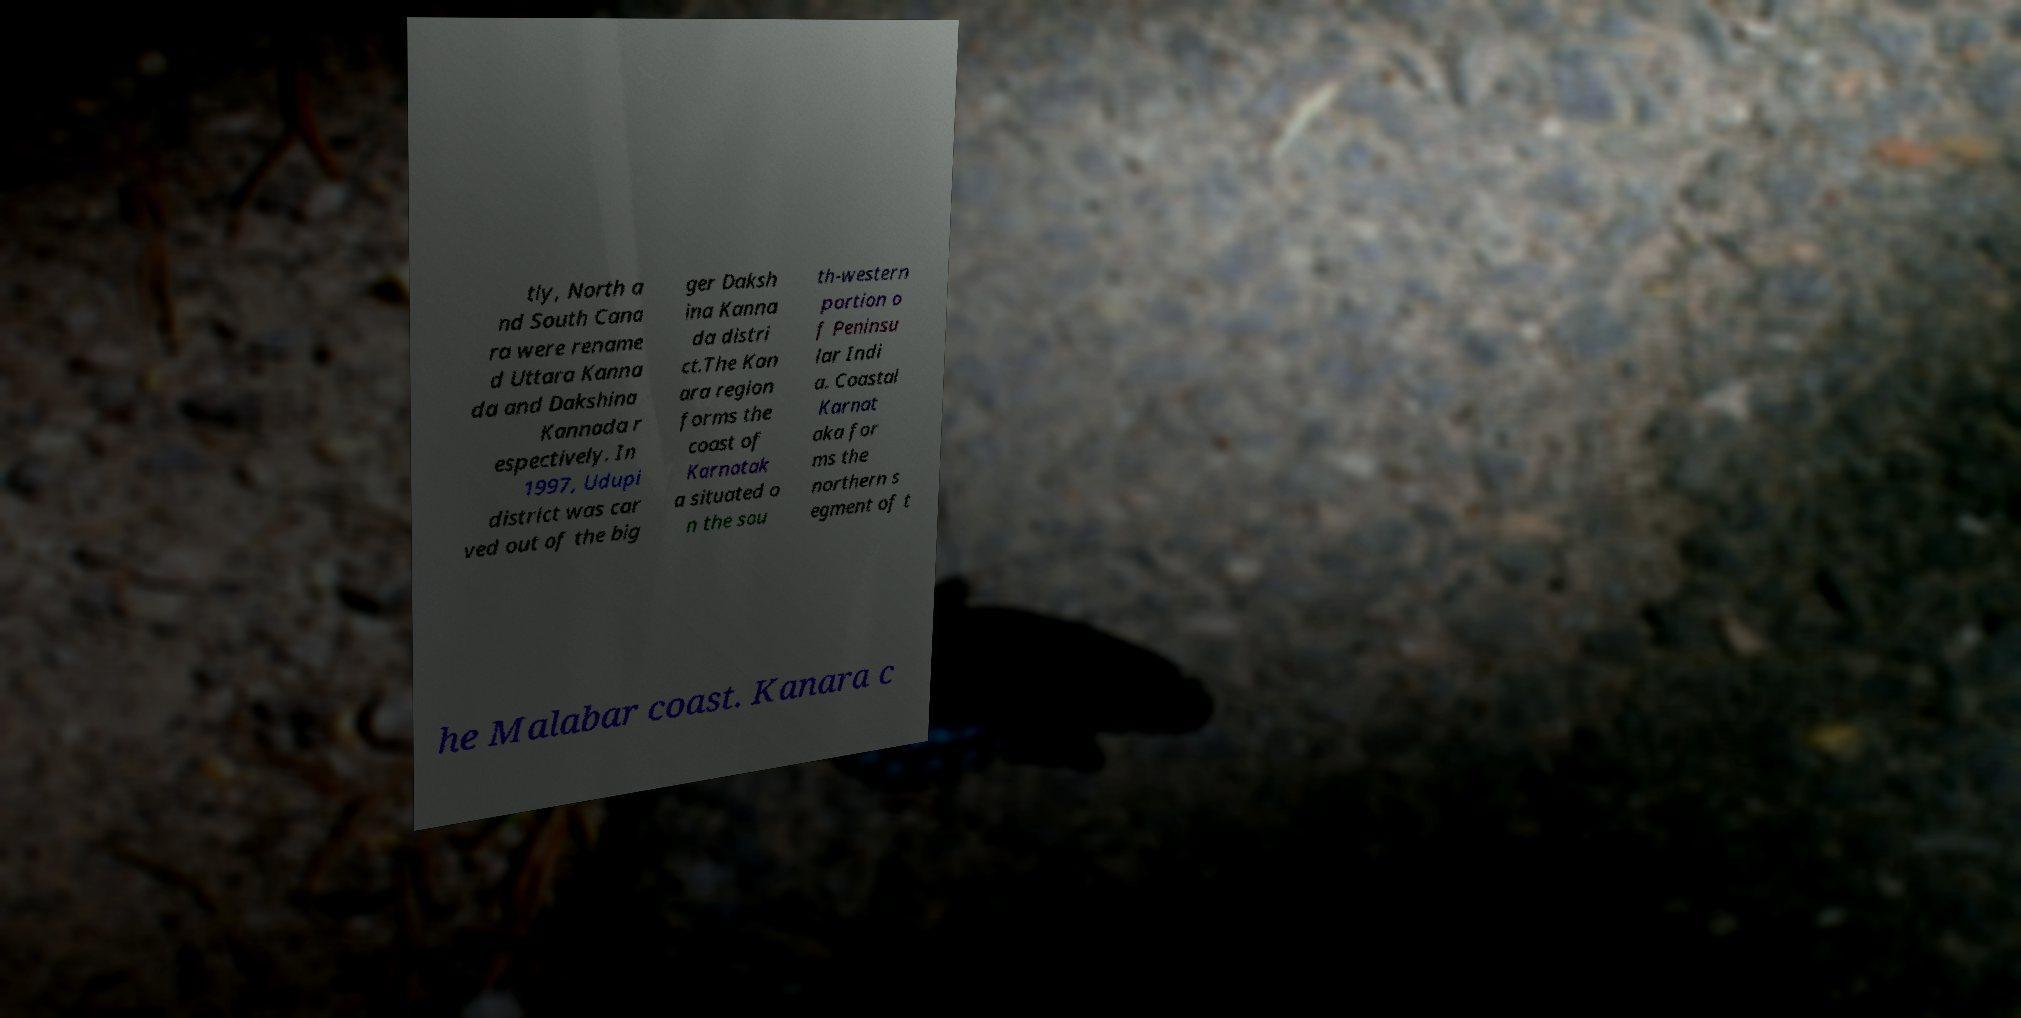Can you read and provide the text displayed in the image?This photo seems to have some interesting text. Can you extract and type it out for me? tly, North a nd South Cana ra were rename d Uttara Kanna da and Dakshina Kannada r espectively. In 1997, Udupi district was car ved out of the big ger Daksh ina Kanna da distri ct.The Kan ara region forms the coast of Karnatak a situated o n the sou th-western portion o f Peninsu lar Indi a. Coastal Karnat aka for ms the northern s egment of t he Malabar coast. Kanara c 